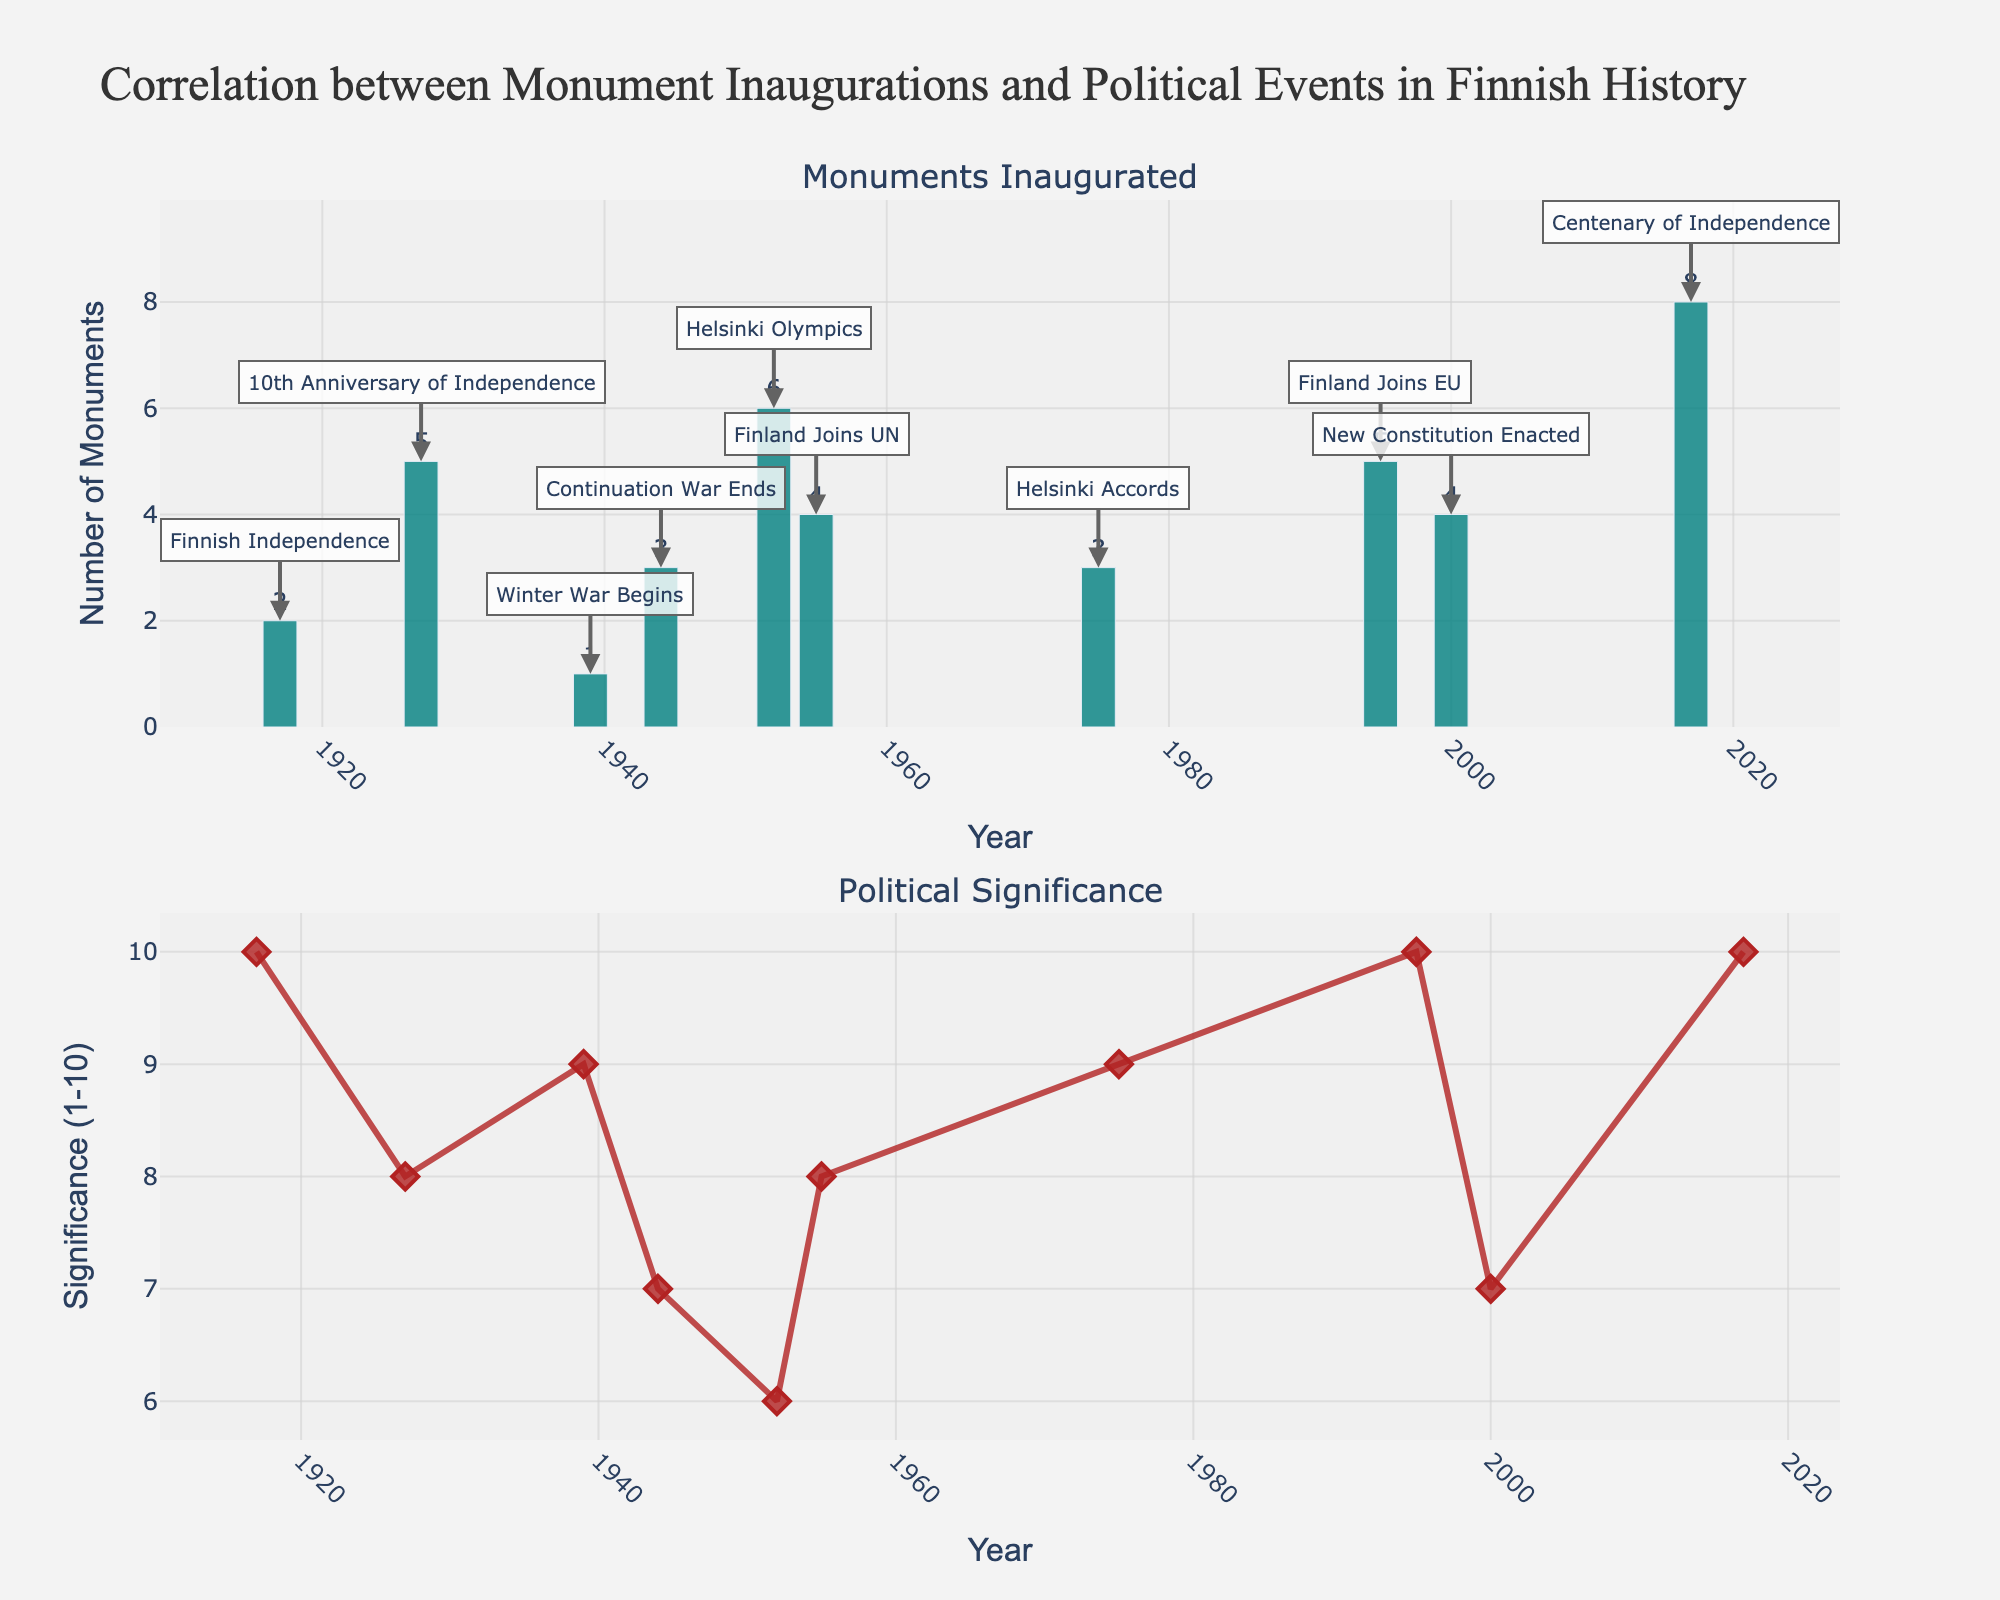What's the title of the figure? The title is positioned at the top of the figure. It reads "Fantasy Subgenres Sales Trends (2013-2023)".
Answer: Fantasy Subgenres Sales Trends (2013-2023) How many subplots are there? By counting the individual horizontal segments subdividing the graph, you can identify there are five subplots.
Answer: Five Which subgenre has shown the highest sales growth from 2013 to 2023? By looking at the initial and final points on each subplot, we can calculate the difference for each subgenre. "Epic Fantasy" sales rise from 1,200,000 to 1,900,000 which is a growth of 700,000, which is the highest among all subgenres.
Answer: Epic Fantasy What has been the trend for "Sword and Sorcery" sales over the years? Examining the trendline in the Sword and Sorcery subplot shows a gradual decline from 520,000 in 2013 to 450,000 in 2023.
Answer: Declining What is the combined sales value for "Urban Fantasy" and "Dark Fantasy" in 2021? From the data points for Urban Fantasy (1,580,000) and Dark Fantasy (1,100,000) in 2021, adding them together gives 1,580,000 + 1,100,000 = 2,680,000.
Answer: 2,680,000 Which subgenre had the lowest sales in 2015? Moving across the 2015 tick on each subplot to find the lowest y-value shows "Sword and Sorcery" having 480,000 sales, which is the smallest of any subgenre that year.
Answer: Sword and Sorcery What year did "Historical Fantasy" surpass 600,000 in sales? Tracing the Historical Fantasy subplot from left to right, the sales reached 620,000 in 2019, which is the first year it surpasses 600,000 sales.
Answer: 2019 What is the average sales value of "Epic Fantasy" across the decade? Summing up the Epic Fantasy values for all years (1,200,000 + 1,350,000 + 1,450,000 + 1,600,000 + 1,750,000 + 1,900,000) equals to 8,250,000, and dividing by the number of years (6) gives an average of 1,375,000.
Answer: 1,375,000 By how much did "Dark Fantasy" sales increase between 2017 and 2023? Dark Fantasy sales were 890,000 in 2017 and increased to 1,250,000 in 2023, which is a difference of 1,250,000 - 890,000 = 360,000.
Answer: 360,000 